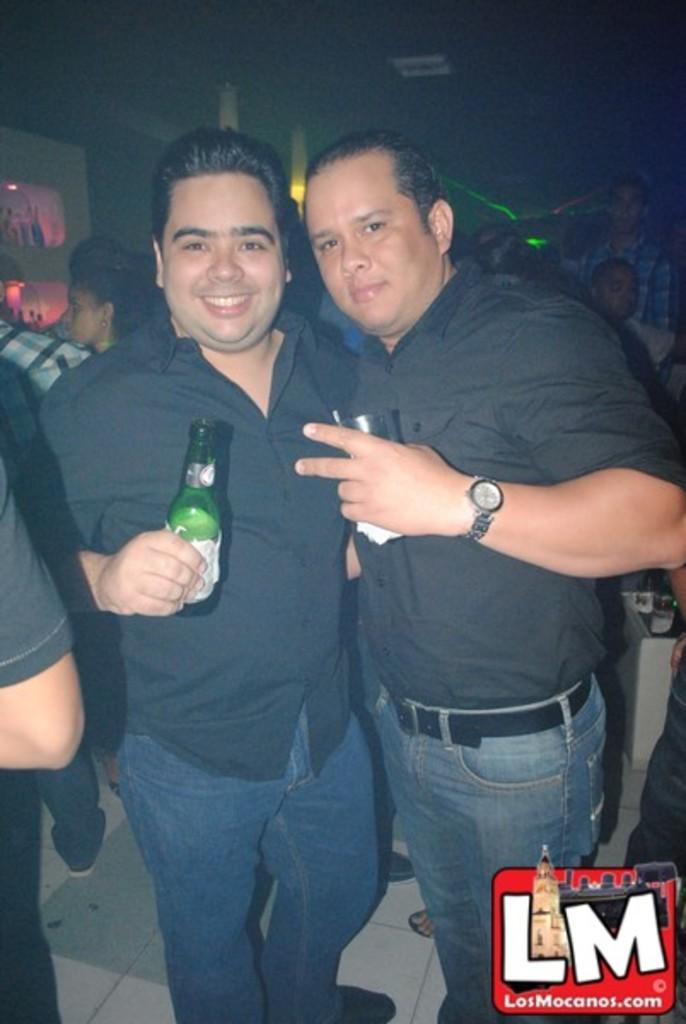How many people are present in the image? There are two men standing in the image. What is one of the men holding in his hand? One of the men is holding a wine bottle in his hand. What type of brass instrument is being played by the man holding the wine bottle? There is no brass instrument present in the image; the man is only holding a wine bottle. What knowledge can be gained from the dog in the image? There is no dog present in the image, so no knowledge can be gained from a dog. 